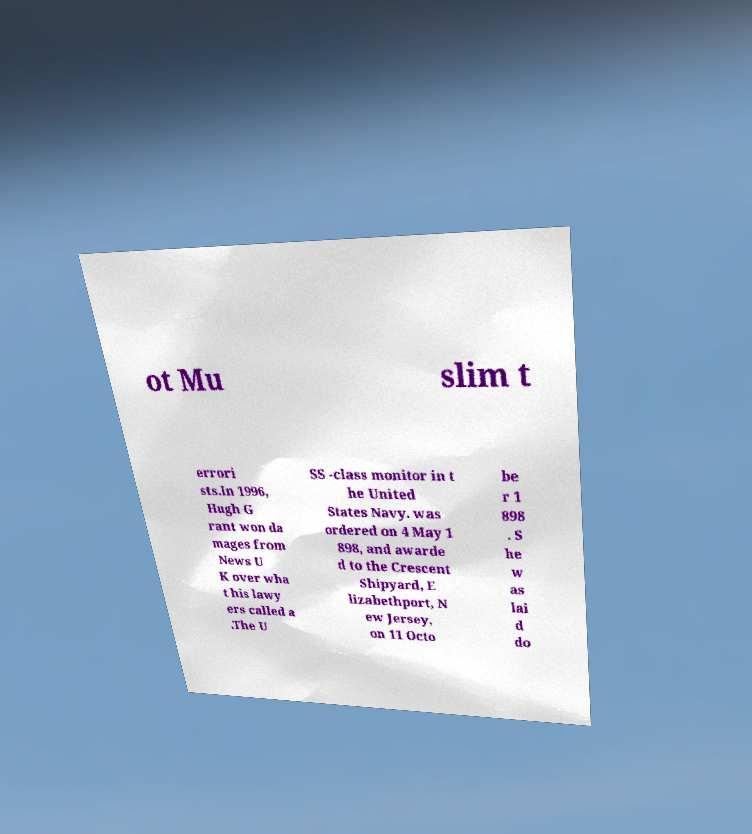What messages or text are displayed in this image? I need them in a readable, typed format. ot Mu slim t errori sts.In 1996, Hugh G rant won da mages from News U K over wha t his lawy ers called a .The U SS -class monitor in t he United States Navy. was ordered on 4 May 1 898, and awarde d to the Crescent Shipyard, E lizabethport, N ew Jersey, on 11 Octo be r 1 898 . S he w as lai d do 